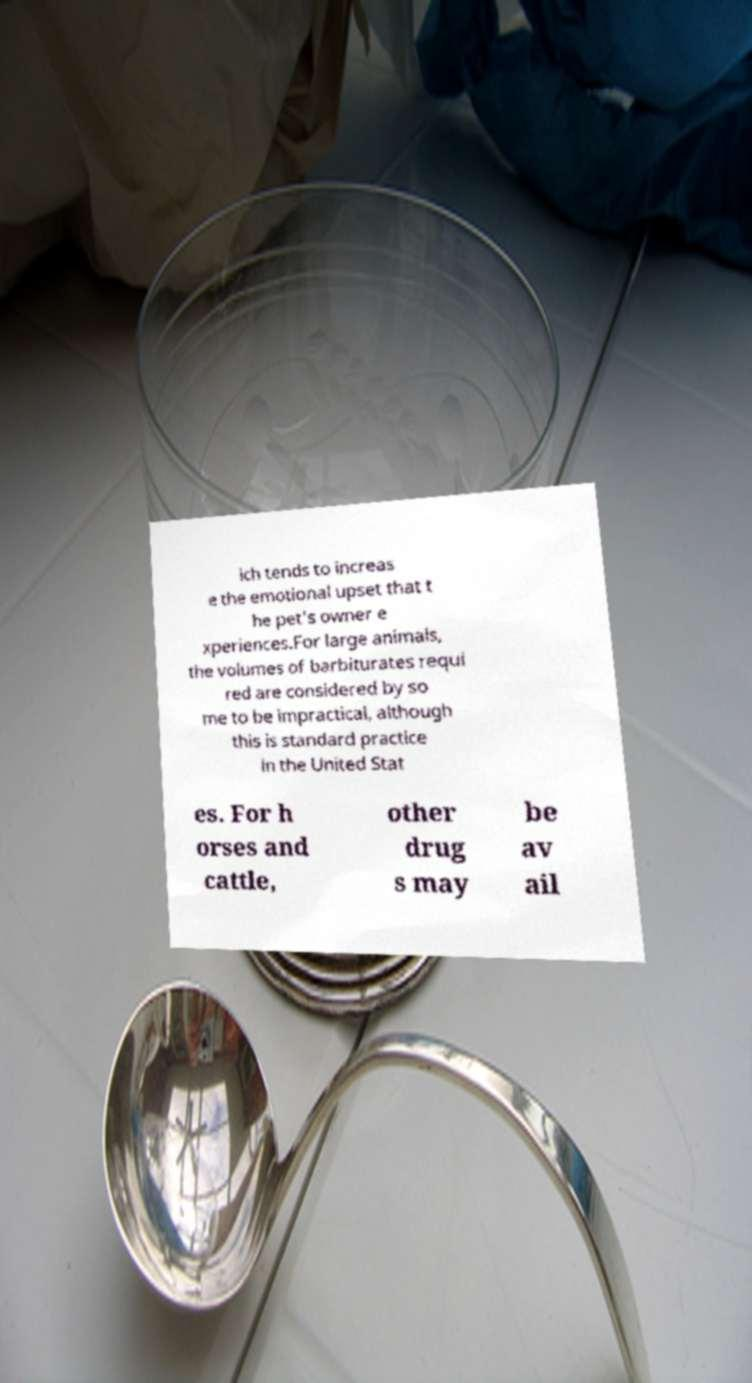I need the written content from this picture converted into text. Can you do that? ich tends to increas e the emotional upset that t he pet's owner e xperiences.For large animals, the volumes of barbiturates requi red are considered by so me to be impractical, although this is standard practice in the United Stat es. For h orses and cattle, other drug s may be av ail 